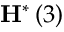<formula> <loc_0><loc_0><loc_500><loc_500>H ^ { * } \left ( 3 \right )</formula> 